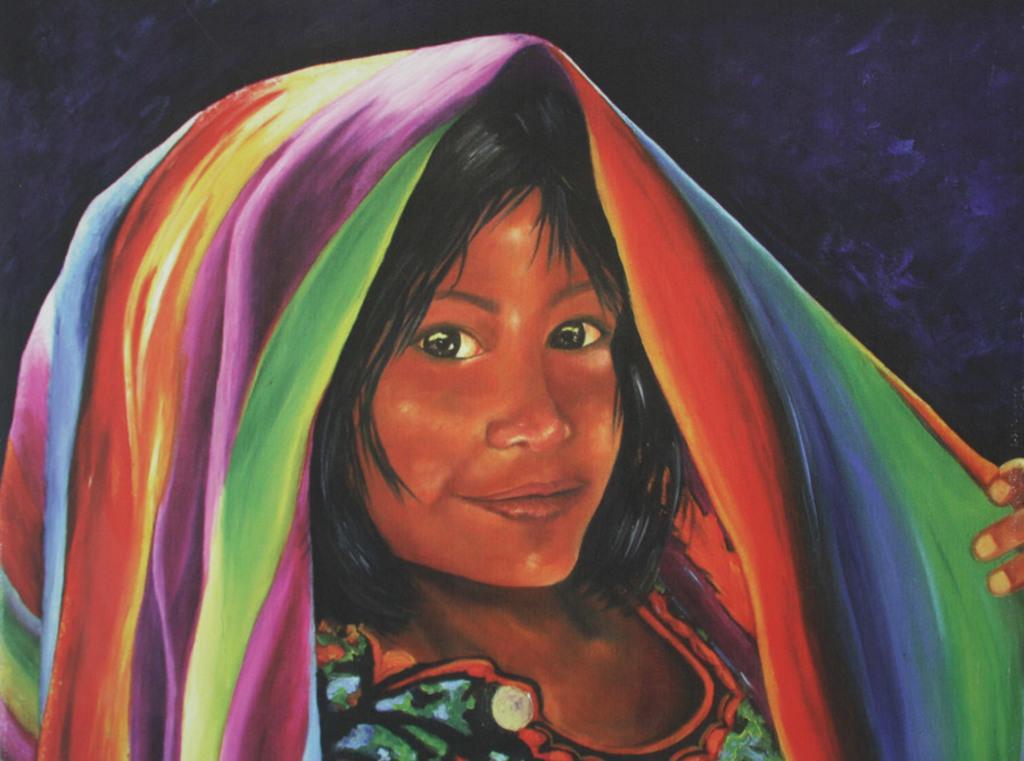How would you summarize this image in a sentence or two? In this image I can see the painting of the person wearing the colorful dress. And there is a black and purple color background. 